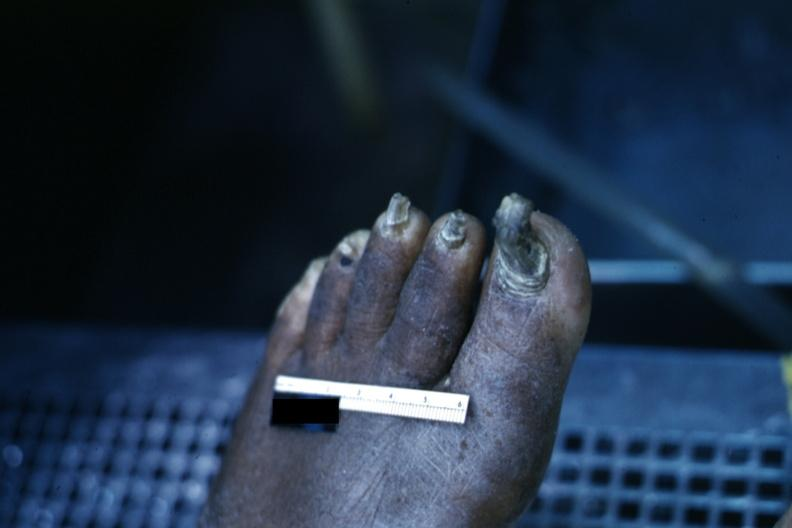s trophic changes present?
Answer the question using a single word or phrase. Yes 